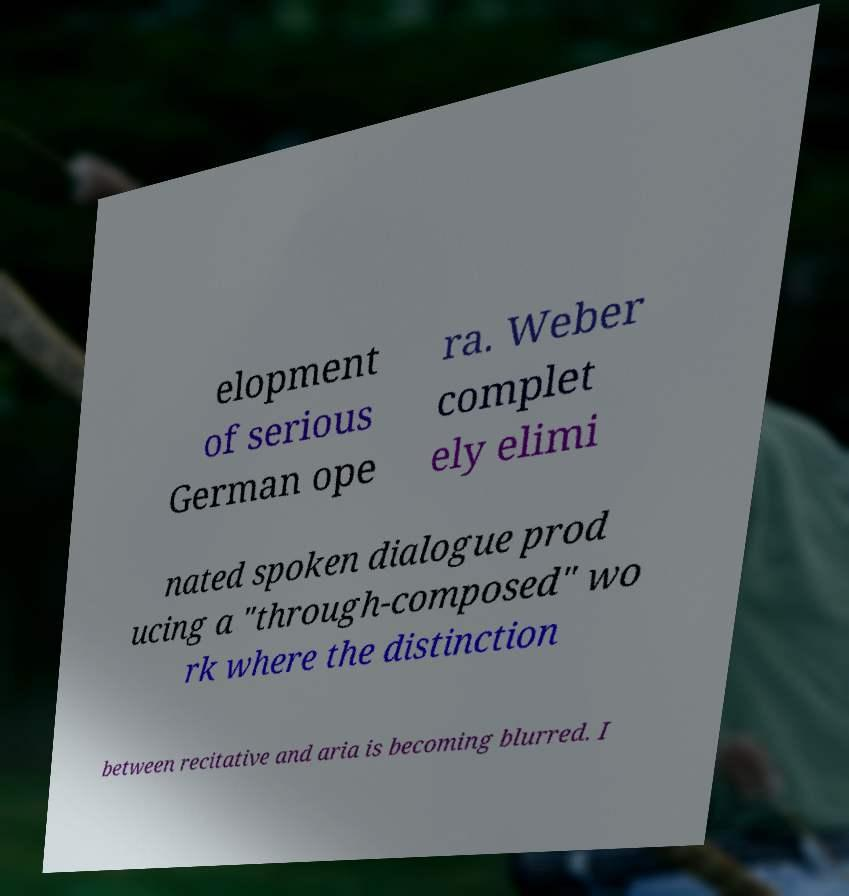Please read and relay the text visible in this image. What does it say? elopment of serious German ope ra. Weber complet ely elimi nated spoken dialogue prod ucing a "through-composed" wo rk where the distinction between recitative and aria is becoming blurred. I 